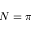Convert formula to latex. <formula><loc_0><loc_0><loc_500><loc_500>N = \pi</formula> 